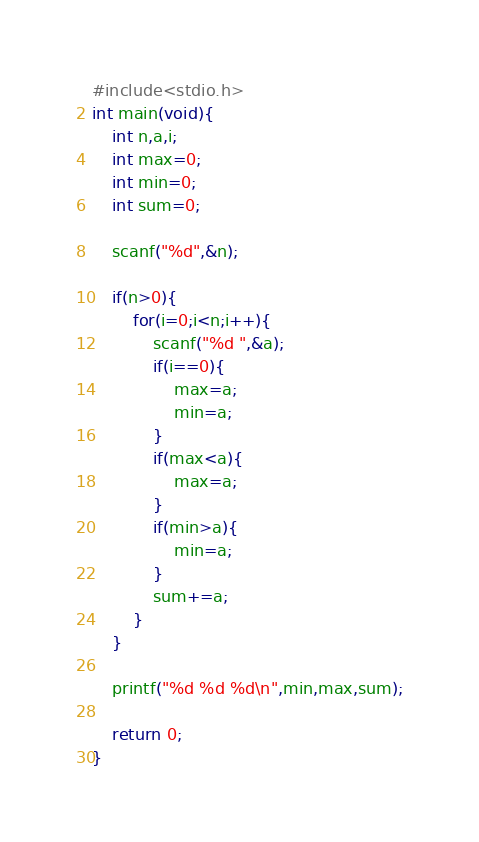<code> <loc_0><loc_0><loc_500><loc_500><_C_>#include<stdio.h>
int main(void){
	int n,a,i;
	int max=0;
	int min=0;
	int sum=0;
	
	scanf("%d",&n);
	
	if(n>0){
		for(i=0;i<n;i++){
			scanf("%d ",&a);
			if(i==0){
				max=a;
				min=a;
			}
			if(max<a){
				max=a;
			}
			if(min>a){
				min=a;
			}
			sum+=a;
		}
	}
	
	printf("%d %d %d\n",min,max,sum);
	
	return 0;
}</code> 